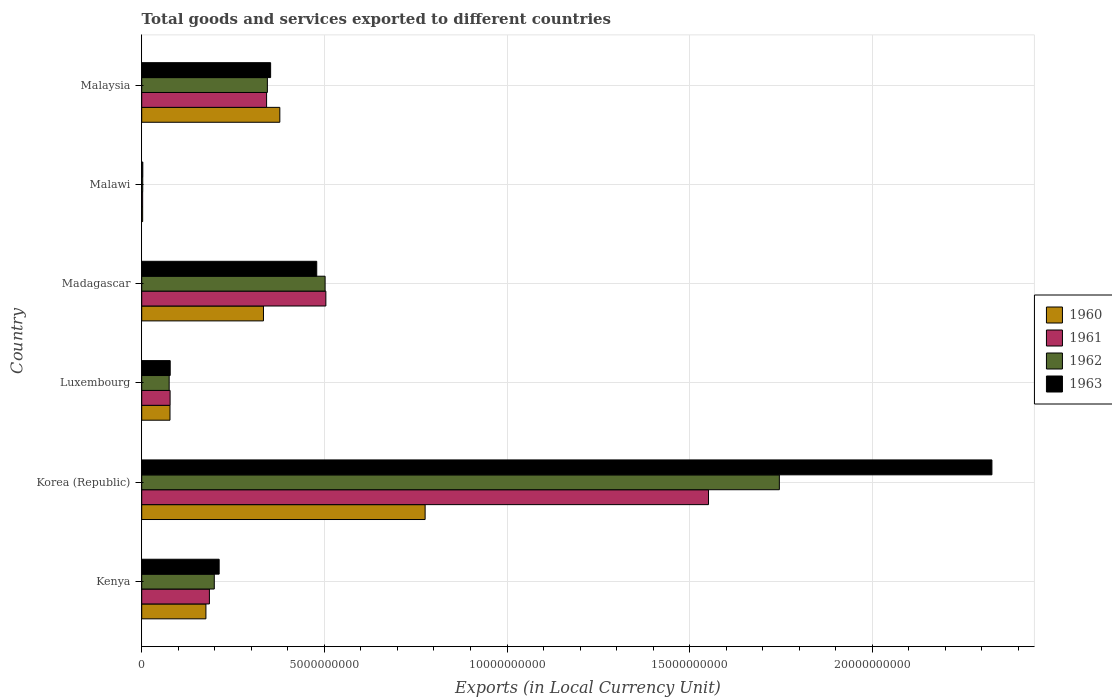How many different coloured bars are there?
Provide a succinct answer. 4. Are the number of bars on each tick of the Y-axis equal?
Your answer should be compact. Yes. How many bars are there on the 6th tick from the top?
Your response must be concise. 4. What is the label of the 4th group of bars from the top?
Ensure brevity in your answer.  Luxembourg. In how many cases, is the number of bars for a given country not equal to the number of legend labels?
Your answer should be very brief. 0. What is the Amount of goods and services exports in 1961 in Madagascar?
Give a very brief answer. 5.04e+09. Across all countries, what is the maximum Amount of goods and services exports in 1963?
Make the answer very short. 2.33e+1. Across all countries, what is the minimum Amount of goods and services exports in 1961?
Keep it short and to the point. 2.57e+07. In which country was the Amount of goods and services exports in 1962 minimum?
Ensure brevity in your answer.  Malawi. What is the total Amount of goods and services exports in 1961 in the graph?
Your response must be concise. 2.66e+1. What is the difference between the Amount of goods and services exports in 1962 in Kenya and that in Malawi?
Make the answer very short. 1.96e+09. What is the difference between the Amount of goods and services exports in 1961 in Malaysia and the Amount of goods and services exports in 1960 in Madagascar?
Offer a terse response. 8.57e+07. What is the average Amount of goods and services exports in 1961 per country?
Your response must be concise. 4.44e+09. What is the difference between the Amount of goods and services exports in 1961 and Amount of goods and services exports in 1960 in Kenya?
Offer a very short reply. 9.56e+07. What is the ratio of the Amount of goods and services exports in 1963 in Madagascar to that in Malawi?
Your response must be concise. 160.78. Is the difference between the Amount of goods and services exports in 1961 in Korea (Republic) and Madagascar greater than the difference between the Amount of goods and services exports in 1960 in Korea (Republic) and Madagascar?
Make the answer very short. Yes. What is the difference between the highest and the second highest Amount of goods and services exports in 1963?
Offer a terse response. 1.85e+1. What is the difference between the highest and the lowest Amount of goods and services exports in 1961?
Provide a succinct answer. 1.55e+1. In how many countries, is the Amount of goods and services exports in 1962 greater than the average Amount of goods and services exports in 1962 taken over all countries?
Give a very brief answer. 2. Is it the case that in every country, the sum of the Amount of goods and services exports in 1961 and Amount of goods and services exports in 1963 is greater than the sum of Amount of goods and services exports in 1962 and Amount of goods and services exports in 1960?
Keep it short and to the point. No. What does the 1st bar from the top in Luxembourg represents?
Your response must be concise. 1963. What does the 1st bar from the bottom in Madagascar represents?
Keep it short and to the point. 1960. What is the difference between two consecutive major ticks on the X-axis?
Your response must be concise. 5.00e+09. Are the values on the major ticks of X-axis written in scientific E-notation?
Make the answer very short. No. Does the graph contain grids?
Your answer should be very brief. Yes. Where does the legend appear in the graph?
Ensure brevity in your answer.  Center right. How many legend labels are there?
Offer a very short reply. 4. How are the legend labels stacked?
Offer a very short reply. Vertical. What is the title of the graph?
Make the answer very short. Total goods and services exported to different countries. What is the label or title of the X-axis?
Your answer should be very brief. Exports (in Local Currency Unit). What is the Exports (in Local Currency Unit) in 1960 in Kenya?
Your answer should be compact. 1.76e+09. What is the Exports (in Local Currency Unit) of 1961 in Kenya?
Give a very brief answer. 1.85e+09. What is the Exports (in Local Currency Unit) in 1962 in Kenya?
Your answer should be compact. 1.99e+09. What is the Exports (in Local Currency Unit) of 1963 in Kenya?
Provide a succinct answer. 2.12e+09. What is the Exports (in Local Currency Unit) in 1960 in Korea (Republic)?
Your answer should be compact. 7.76e+09. What is the Exports (in Local Currency Unit) of 1961 in Korea (Republic)?
Provide a succinct answer. 1.55e+1. What is the Exports (in Local Currency Unit) in 1962 in Korea (Republic)?
Provide a short and direct response. 1.75e+1. What is the Exports (in Local Currency Unit) in 1963 in Korea (Republic)?
Keep it short and to the point. 2.33e+1. What is the Exports (in Local Currency Unit) in 1960 in Luxembourg?
Make the answer very short. 7.74e+08. What is the Exports (in Local Currency Unit) of 1961 in Luxembourg?
Your answer should be compact. 7.77e+08. What is the Exports (in Local Currency Unit) in 1962 in Luxembourg?
Your answer should be very brief. 7.52e+08. What is the Exports (in Local Currency Unit) of 1963 in Luxembourg?
Keep it short and to the point. 7.80e+08. What is the Exports (in Local Currency Unit) of 1960 in Madagascar?
Your response must be concise. 3.33e+09. What is the Exports (in Local Currency Unit) in 1961 in Madagascar?
Make the answer very short. 5.04e+09. What is the Exports (in Local Currency Unit) in 1962 in Madagascar?
Keep it short and to the point. 5.02e+09. What is the Exports (in Local Currency Unit) of 1963 in Madagascar?
Offer a terse response. 4.79e+09. What is the Exports (in Local Currency Unit) in 1960 in Malawi?
Provide a short and direct response. 2.57e+07. What is the Exports (in Local Currency Unit) of 1961 in Malawi?
Offer a very short reply. 2.57e+07. What is the Exports (in Local Currency Unit) in 1962 in Malawi?
Offer a terse response. 2.80e+07. What is the Exports (in Local Currency Unit) in 1963 in Malawi?
Offer a very short reply. 2.98e+07. What is the Exports (in Local Currency Unit) in 1960 in Malaysia?
Offer a very short reply. 3.78e+09. What is the Exports (in Local Currency Unit) in 1961 in Malaysia?
Keep it short and to the point. 3.42e+09. What is the Exports (in Local Currency Unit) in 1962 in Malaysia?
Provide a short and direct response. 3.44e+09. What is the Exports (in Local Currency Unit) of 1963 in Malaysia?
Your answer should be compact. 3.53e+09. Across all countries, what is the maximum Exports (in Local Currency Unit) in 1960?
Your answer should be compact. 7.76e+09. Across all countries, what is the maximum Exports (in Local Currency Unit) in 1961?
Ensure brevity in your answer.  1.55e+1. Across all countries, what is the maximum Exports (in Local Currency Unit) of 1962?
Make the answer very short. 1.75e+1. Across all countries, what is the maximum Exports (in Local Currency Unit) of 1963?
Make the answer very short. 2.33e+1. Across all countries, what is the minimum Exports (in Local Currency Unit) in 1960?
Provide a short and direct response. 2.57e+07. Across all countries, what is the minimum Exports (in Local Currency Unit) of 1961?
Ensure brevity in your answer.  2.57e+07. Across all countries, what is the minimum Exports (in Local Currency Unit) in 1962?
Ensure brevity in your answer.  2.80e+07. Across all countries, what is the minimum Exports (in Local Currency Unit) of 1963?
Make the answer very short. 2.98e+07. What is the total Exports (in Local Currency Unit) in 1960 in the graph?
Your answer should be compact. 1.74e+1. What is the total Exports (in Local Currency Unit) in 1961 in the graph?
Your answer should be compact. 2.66e+1. What is the total Exports (in Local Currency Unit) of 1962 in the graph?
Offer a terse response. 2.87e+1. What is the total Exports (in Local Currency Unit) of 1963 in the graph?
Make the answer very short. 3.45e+1. What is the difference between the Exports (in Local Currency Unit) in 1960 in Kenya and that in Korea (Republic)?
Offer a very short reply. -6.00e+09. What is the difference between the Exports (in Local Currency Unit) in 1961 in Kenya and that in Korea (Republic)?
Offer a very short reply. -1.37e+1. What is the difference between the Exports (in Local Currency Unit) in 1962 in Kenya and that in Korea (Republic)?
Keep it short and to the point. -1.55e+1. What is the difference between the Exports (in Local Currency Unit) in 1963 in Kenya and that in Korea (Republic)?
Ensure brevity in your answer.  -2.12e+1. What is the difference between the Exports (in Local Currency Unit) of 1960 in Kenya and that in Luxembourg?
Your answer should be very brief. 9.84e+08. What is the difference between the Exports (in Local Currency Unit) in 1961 in Kenya and that in Luxembourg?
Offer a very short reply. 1.08e+09. What is the difference between the Exports (in Local Currency Unit) of 1962 in Kenya and that in Luxembourg?
Provide a short and direct response. 1.23e+09. What is the difference between the Exports (in Local Currency Unit) in 1963 in Kenya and that in Luxembourg?
Provide a short and direct response. 1.34e+09. What is the difference between the Exports (in Local Currency Unit) of 1960 in Kenya and that in Madagascar?
Make the answer very short. -1.58e+09. What is the difference between the Exports (in Local Currency Unit) of 1961 in Kenya and that in Madagascar?
Offer a very short reply. -3.19e+09. What is the difference between the Exports (in Local Currency Unit) of 1962 in Kenya and that in Madagascar?
Provide a succinct answer. -3.03e+09. What is the difference between the Exports (in Local Currency Unit) of 1963 in Kenya and that in Madagascar?
Make the answer very short. -2.67e+09. What is the difference between the Exports (in Local Currency Unit) in 1960 in Kenya and that in Malawi?
Ensure brevity in your answer.  1.73e+09. What is the difference between the Exports (in Local Currency Unit) of 1961 in Kenya and that in Malawi?
Your response must be concise. 1.83e+09. What is the difference between the Exports (in Local Currency Unit) in 1962 in Kenya and that in Malawi?
Your answer should be compact. 1.96e+09. What is the difference between the Exports (in Local Currency Unit) in 1963 in Kenya and that in Malawi?
Make the answer very short. 2.09e+09. What is the difference between the Exports (in Local Currency Unit) in 1960 in Kenya and that in Malaysia?
Provide a short and direct response. -2.02e+09. What is the difference between the Exports (in Local Currency Unit) in 1961 in Kenya and that in Malaysia?
Provide a short and direct response. -1.57e+09. What is the difference between the Exports (in Local Currency Unit) in 1962 in Kenya and that in Malaysia?
Your response must be concise. -1.45e+09. What is the difference between the Exports (in Local Currency Unit) in 1963 in Kenya and that in Malaysia?
Give a very brief answer. -1.41e+09. What is the difference between the Exports (in Local Currency Unit) in 1960 in Korea (Republic) and that in Luxembourg?
Provide a short and direct response. 6.98e+09. What is the difference between the Exports (in Local Currency Unit) in 1961 in Korea (Republic) and that in Luxembourg?
Ensure brevity in your answer.  1.47e+1. What is the difference between the Exports (in Local Currency Unit) in 1962 in Korea (Republic) and that in Luxembourg?
Keep it short and to the point. 1.67e+1. What is the difference between the Exports (in Local Currency Unit) in 1963 in Korea (Republic) and that in Luxembourg?
Make the answer very short. 2.25e+1. What is the difference between the Exports (in Local Currency Unit) of 1960 in Korea (Republic) and that in Madagascar?
Your response must be concise. 4.43e+09. What is the difference between the Exports (in Local Currency Unit) in 1961 in Korea (Republic) and that in Madagascar?
Offer a very short reply. 1.05e+1. What is the difference between the Exports (in Local Currency Unit) of 1962 in Korea (Republic) and that in Madagascar?
Your response must be concise. 1.24e+1. What is the difference between the Exports (in Local Currency Unit) in 1963 in Korea (Republic) and that in Madagascar?
Offer a terse response. 1.85e+1. What is the difference between the Exports (in Local Currency Unit) of 1960 in Korea (Republic) and that in Malawi?
Offer a terse response. 7.73e+09. What is the difference between the Exports (in Local Currency Unit) in 1961 in Korea (Republic) and that in Malawi?
Offer a very short reply. 1.55e+1. What is the difference between the Exports (in Local Currency Unit) in 1962 in Korea (Republic) and that in Malawi?
Provide a short and direct response. 1.74e+1. What is the difference between the Exports (in Local Currency Unit) in 1963 in Korea (Republic) and that in Malawi?
Ensure brevity in your answer.  2.32e+1. What is the difference between the Exports (in Local Currency Unit) of 1960 in Korea (Republic) and that in Malaysia?
Give a very brief answer. 3.98e+09. What is the difference between the Exports (in Local Currency Unit) of 1961 in Korea (Republic) and that in Malaysia?
Provide a succinct answer. 1.21e+1. What is the difference between the Exports (in Local Currency Unit) of 1962 in Korea (Republic) and that in Malaysia?
Ensure brevity in your answer.  1.40e+1. What is the difference between the Exports (in Local Currency Unit) in 1963 in Korea (Republic) and that in Malaysia?
Ensure brevity in your answer.  1.97e+1. What is the difference between the Exports (in Local Currency Unit) in 1960 in Luxembourg and that in Madagascar?
Your answer should be compact. -2.56e+09. What is the difference between the Exports (in Local Currency Unit) in 1961 in Luxembourg and that in Madagascar?
Ensure brevity in your answer.  -4.26e+09. What is the difference between the Exports (in Local Currency Unit) of 1962 in Luxembourg and that in Madagascar?
Make the answer very short. -4.27e+09. What is the difference between the Exports (in Local Currency Unit) of 1963 in Luxembourg and that in Madagascar?
Your answer should be compact. -4.01e+09. What is the difference between the Exports (in Local Currency Unit) in 1960 in Luxembourg and that in Malawi?
Your answer should be very brief. 7.48e+08. What is the difference between the Exports (in Local Currency Unit) of 1961 in Luxembourg and that in Malawi?
Your response must be concise. 7.51e+08. What is the difference between the Exports (in Local Currency Unit) in 1962 in Luxembourg and that in Malawi?
Your answer should be compact. 7.24e+08. What is the difference between the Exports (in Local Currency Unit) in 1963 in Luxembourg and that in Malawi?
Ensure brevity in your answer.  7.50e+08. What is the difference between the Exports (in Local Currency Unit) in 1960 in Luxembourg and that in Malaysia?
Provide a short and direct response. -3.01e+09. What is the difference between the Exports (in Local Currency Unit) in 1961 in Luxembourg and that in Malaysia?
Offer a terse response. -2.64e+09. What is the difference between the Exports (in Local Currency Unit) of 1962 in Luxembourg and that in Malaysia?
Your response must be concise. -2.69e+09. What is the difference between the Exports (in Local Currency Unit) in 1963 in Luxembourg and that in Malaysia?
Your response must be concise. -2.75e+09. What is the difference between the Exports (in Local Currency Unit) of 1960 in Madagascar and that in Malawi?
Make the answer very short. 3.31e+09. What is the difference between the Exports (in Local Currency Unit) in 1961 in Madagascar and that in Malawi?
Offer a terse response. 5.02e+09. What is the difference between the Exports (in Local Currency Unit) of 1962 in Madagascar and that in Malawi?
Make the answer very short. 4.99e+09. What is the difference between the Exports (in Local Currency Unit) in 1963 in Madagascar and that in Malawi?
Your answer should be compact. 4.76e+09. What is the difference between the Exports (in Local Currency Unit) in 1960 in Madagascar and that in Malaysia?
Your response must be concise. -4.48e+08. What is the difference between the Exports (in Local Currency Unit) in 1961 in Madagascar and that in Malaysia?
Provide a succinct answer. 1.62e+09. What is the difference between the Exports (in Local Currency Unit) in 1962 in Madagascar and that in Malaysia?
Make the answer very short. 1.58e+09. What is the difference between the Exports (in Local Currency Unit) of 1963 in Madagascar and that in Malaysia?
Give a very brief answer. 1.26e+09. What is the difference between the Exports (in Local Currency Unit) of 1960 in Malawi and that in Malaysia?
Make the answer very short. -3.76e+09. What is the difference between the Exports (in Local Currency Unit) in 1961 in Malawi and that in Malaysia?
Give a very brief answer. -3.39e+09. What is the difference between the Exports (in Local Currency Unit) in 1962 in Malawi and that in Malaysia?
Your answer should be compact. -3.41e+09. What is the difference between the Exports (in Local Currency Unit) in 1963 in Malawi and that in Malaysia?
Give a very brief answer. -3.50e+09. What is the difference between the Exports (in Local Currency Unit) in 1960 in Kenya and the Exports (in Local Currency Unit) in 1961 in Korea (Republic)?
Provide a succinct answer. -1.38e+1. What is the difference between the Exports (in Local Currency Unit) of 1960 in Kenya and the Exports (in Local Currency Unit) of 1962 in Korea (Republic)?
Keep it short and to the point. -1.57e+1. What is the difference between the Exports (in Local Currency Unit) of 1960 in Kenya and the Exports (in Local Currency Unit) of 1963 in Korea (Republic)?
Offer a very short reply. -2.15e+1. What is the difference between the Exports (in Local Currency Unit) of 1961 in Kenya and the Exports (in Local Currency Unit) of 1962 in Korea (Republic)?
Your answer should be very brief. -1.56e+1. What is the difference between the Exports (in Local Currency Unit) of 1961 in Kenya and the Exports (in Local Currency Unit) of 1963 in Korea (Republic)?
Your response must be concise. -2.14e+1. What is the difference between the Exports (in Local Currency Unit) in 1962 in Kenya and the Exports (in Local Currency Unit) in 1963 in Korea (Republic)?
Your response must be concise. -2.13e+1. What is the difference between the Exports (in Local Currency Unit) of 1960 in Kenya and the Exports (in Local Currency Unit) of 1961 in Luxembourg?
Give a very brief answer. 9.81e+08. What is the difference between the Exports (in Local Currency Unit) in 1960 in Kenya and the Exports (in Local Currency Unit) in 1962 in Luxembourg?
Provide a short and direct response. 1.01e+09. What is the difference between the Exports (in Local Currency Unit) of 1960 in Kenya and the Exports (in Local Currency Unit) of 1963 in Luxembourg?
Give a very brief answer. 9.78e+08. What is the difference between the Exports (in Local Currency Unit) in 1961 in Kenya and the Exports (in Local Currency Unit) in 1962 in Luxembourg?
Your answer should be very brief. 1.10e+09. What is the difference between the Exports (in Local Currency Unit) of 1961 in Kenya and the Exports (in Local Currency Unit) of 1963 in Luxembourg?
Ensure brevity in your answer.  1.07e+09. What is the difference between the Exports (in Local Currency Unit) in 1962 in Kenya and the Exports (in Local Currency Unit) in 1963 in Luxembourg?
Provide a short and direct response. 1.21e+09. What is the difference between the Exports (in Local Currency Unit) of 1960 in Kenya and the Exports (in Local Currency Unit) of 1961 in Madagascar?
Ensure brevity in your answer.  -3.28e+09. What is the difference between the Exports (in Local Currency Unit) of 1960 in Kenya and the Exports (in Local Currency Unit) of 1962 in Madagascar?
Give a very brief answer. -3.26e+09. What is the difference between the Exports (in Local Currency Unit) in 1960 in Kenya and the Exports (in Local Currency Unit) in 1963 in Madagascar?
Ensure brevity in your answer.  -3.03e+09. What is the difference between the Exports (in Local Currency Unit) in 1961 in Kenya and the Exports (in Local Currency Unit) in 1962 in Madagascar?
Offer a terse response. -3.17e+09. What is the difference between the Exports (in Local Currency Unit) in 1961 in Kenya and the Exports (in Local Currency Unit) in 1963 in Madagascar?
Ensure brevity in your answer.  -2.94e+09. What is the difference between the Exports (in Local Currency Unit) of 1962 in Kenya and the Exports (in Local Currency Unit) of 1963 in Madagascar?
Keep it short and to the point. -2.80e+09. What is the difference between the Exports (in Local Currency Unit) in 1960 in Kenya and the Exports (in Local Currency Unit) in 1961 in Malawi?
Make the answer very short. 1.73e+09. What is the difference between the Exports (in Local Currency Unit) of 1960 in Kenya and the Exports (in Local Currency Unit) of 1962 in Malawi?
Provide a succinct answer. 1.73e+09. What is the difference between the Exports (in Local Currency Unit) of 1960 in Kenya and the Exports (in Local Currency Unit) of 1963 in Malawi?
Give a very brief answer. 1.73e+09. What is the difference between the Exports (in Local Currency Unit) in 1961 in Kenya and the Exports (in Local Currency Unit) in 1962 in Malawi?
Offer a very short reply. 1.83e+09. What is the difference between the Exports (in Local Currency Unit) in 1961 in Kenya and the Exports (in Local Currency Unit) in 1963 in Malawi?
Give a very brief answer. 1.82e+09. What is the difference between the Exports (in Local Currency Unit) in 1962 in Kenya and the Exports (in Local Currency Unit) in 1963 in Malawi?
Offer a very short reply. 1.96e+09. What is the difference between the Exports (in Local Currency Unit) in 1960 in Kenya and the Exports (in Local Currency Unit) in 1961 in Malaysia?
Your answer should be compact. -1.66e+09. What is the difference between the Exports (in Local Currency Unit) in 1960 in Kenya and the Exports (in Local Currency Unit) in 1962 in Malaysia?
Offer a terse response. -1.68e+09. What is the difference between the Exports (in Local Currency Unit) of 1960 in Kenya and the Exports (in Local Currency Unit) of 1963 in Malaysia?
Offer a terse response. -1.77e+09. What is the difference between the Exports (in Local Currency Unit) in 1961 in Kenya and the Exports (in Local Currency Unit) in 1962 in Malaysia?
Offer a terse response. -1.59e+09. What is the difference between the Exports (in Local Currency Unit) in 1961 in Kenya and the Exports (in Local Currency Unit) in 1963 in Malaysia?
Keep it short and to the point. -1.68e+09. What is the difference between the Exports (in Local Currency Unit) of 1962 in Kenya and the Exports (in Local Currency Unit) of 1963 in Malaysia?
Provide a succinct answer. -1.54e+09. What is the difference between the Exports (in Local Currency Unit) in 1960 in Korea (Republic) and the Exports (in Local Currency Unit) in 1961 in Luxembourg?
Ensure brevity in your answer.  6.98e+09. What is the difference between the Exports (in Local Currency Unit) in 1960 in Korea (Republic) and the Exports (in Local Currency Unit) in 1962 in Luxembourg?
Your answer should be compact. 7.01e+09. What is the difference between the Exports (in Local Currency Unit) in 1960 in Korea (Republic) and the Exports (in Local Currency Unit) in 1963 in Luxembourg?
Your response must be concise. 6.98e+09. What is the difference between the Exports (in Local Currency Unit) in 1961 in Korea (Republic) and the Exports (in Local Currency Unit) in 1962 in Luxembourg?
Provide a succinct answer. 1.48e+1. What is the difference between the Exports (in Local Currency Unit) in 1961 in Korea (Republic) and the Exports (in Local Currency Unit) in 1963 in Luxembourg?
Make the answer very short. 1.47e+1. What is the difference between the Exports (in Local Currency Unit) of 1962 in Korea (Republic) and the Exports (in Local Currency Unit) of 1963 in Luxembourg?
Provide a succinct answer. 1.67e+1. What is the difference between the Exports (in Local Currency Unit) in 1960 in Korea (Republic) and the Exports (in Local Currency Unit) in 1961 in Madagascar?
Provide a short and direct response. 2.72e+09. What is the difference between the Exports (in Local Currency Unit) of 1960 in Korea (Republic) and the Exports (in Local Currency Unit) of 1962 in Madagascar?
Offer a very short reply. 2.74e+09. What is the difference between the Exports (in Local Currency Unit) in 1960 in Korea (Republic) and the Exports (in Local Currency Unit) in 1963 in Madagascar?
Your answer should be very brief. 2.97e+09. What is the difference between the Exports (in Local Currency Unit) of 1961 in Korea (Republic) and the Exports (in Local Currency Unit) of 1962 in Madagascar?
Offer a very short reply. 1.05e+1. What is the difference between the Exports (in Local Currency Unit) of 1961 in Korea (Republic) and the Exports (in Local Currency Unit) of 1963 in Madagascar?
Provide a succinct answer. 1.07e+1. What is the difference between the Exports (in Local Currency Unit) in 1962 in Korea (Republic) and the Exports (in Local Currency Unit) in 1963 in Madagascar?
Offer a very short reply. 1.27e+1. What is the difference between the Exports (in Local Currency Unit) in 1960 in Korea (Republic) and the Exports (in Local Currency Unit) in 1961 in Malawi?
Your answer should be very brief. 7.73e+09. What is the difference between the Exports (in Local Currency Unit) in 1960 in Korea (Republic) and the Exports (in Local Currency Unit) in 1962 in Malawi?
Keep it short and to the point. 7.73e+09. What is the difference between the Exports (in Local Currency Unit) in 1960 in Korea (Republic) and the Exports (in Local Currency Unit) in 1963 in Malawi?
Your answer should be very brief. 7.73e+09. What is the difference between the Exports (in Local Currency Unit) of 1961 in Korea (Republic) and the Exports (in Local Currency Unit) of 1962 in Malawi?
Your answer should be compact. 1.55e+1. What is the difference between the Exports (in Local Currency Unit) of 1961 in Korea (Republic) and the Exports (in Local Currency Unit) of 1963 in Malawi?
Give a very brief answer. 1.55e+1. What is the difference between the Exports (in Local Currency Unit) in 1962 in Korea (Republic) and the Exports (in Local Currency Unit) in 1963 in Malawi?
Keep it short and to the point. 1.74e+1. What is the difference between the Exports (in Local Currency Unit) of 1960 in Korea (Republic) and the Exports (in Local Currency Unit) of 1961 in Malaysia?
Your answer should be very brief. 4.34e+09. What is the difference between the Exports (in Local Currency Unit) of 1960 in Korea (Republic) and the Exports (in Local Currency Unit) of 1962 in Malaysia?
Offer a very short reply. 4.32e+09. What is the difference between the Exports (in Local Currency Unit) in 1960 in Korea (Republic) and the Exports (in Local Currency Unit) in 1963 in Malaysia?
Your answer should be very brief. 4.23e+09. What is the difference between the Exports (in Local Currency Unit) of 1961 in Korea (Republic) and the Exports (in Local Currency Unit) of 1962 in Malaysia?
Your response must be concise. 1.21e+1. What is the difference between the Exports (in Local Currency Unit) in 1961 in Korea (Republic) and the Exports (in Local Currency Unit) in 1963 in Malaysia?
Ensure brevity in your answer.  1.20e+1. What is the difference between the Exports (in Local Currency Unit) in 1962 in Korea (Republic) and the Exports (in Local Currency Unit) in 1963 in Malaysia?
Provide a short and direct response. 1.39e+1. What is the difference between the Exports (in Local Currency Unit) in 1960 in Luxembourg and the Exports (in Local Currency Unit) in 1961 in Madagascar?
Offer a very short reply. -4.27e+09. What is the difference between the Exports (in Local Currency Unit) of 1960 in Luxembourg and the Exports (in Local Currency Unit) of 1962 in Madagascar?
Your response must be concise. -4.25e+09. What is the difference between the Exports (in Local Currency Unit) in 1960 in Luxembourg and the Exports (in Local Currency Unit) in 1963 in Madagascar?
Your response must be concise. -4.02e+09. What is the difference between the Exports (in Local Currency Unit) of 1961 in Luxembourg and the Exports (in Local Currency Unit) of 1962 in Madagascar?
Offer a terse response. -4.24e+09. What is the difference between the Exports (in Local Currency Unit) in 1961 in Luxembourg and the Exports (in Local Currency Unit) in 1963 in Madagascar?
Your answer should be compact. -4.01e+09. What is the difference between the Exports (in Local Currency Unit) in 1962 in Luxembourg and the Exports (in Local Currency Unit) in 1963 in Madagascar?
Give a very brief answer. -4.04e+09. What is the difference between the Exports (in Local Currency Unit) in 1960 in Luxembourg and the Exports (in Local Currency Unit) in 1961 in Malawi?
Provide a short and direct response. 7.48e+08. What is the difference between the Exports (in Local Currency Unit) of 1960 in Luxembourg and the Exports (in Local Currency Unit) of 1962 in Malawi?
Make the answer very short. 7.46e+08. What is the difference between the Exports (in Local Currency Unit) of 1960 in Luxembourg and the Exports (in Local Currency Unit) of 1963 in Malawi?
Provide a short and direct response. 7.44e+08. What is the difference between the Exports (in Local Currency Unit) of 1961 in Luxembourg and the Exports (in Local Currency Unit) of 1962 in Malawi?
Make the answer very short. 7.49e+08. What is the difference between the Exports (in Local Currency Unit) in 1961 in Luxembourg and the Exports (in Local Currency Unit) in 1963 in Malawi?
Your response must be concise. 7.47e+08. What is the difference between the Exports (in Local Currency Unit) of 1962 in Luxembourg and the Exports (in Local Currency Unit) of 1963 in Malawi?
Offer a terse response. 7.22e+08. What is the difference between the Exports (in Local Currency Unit) in 1960 in Luxembourg and the Exports (in Local Currency Unit) in 1961 in Malaysia?
Your answer should be very brief. -2.64e+09. What is the difference between the Exports (in Local Currency Unit) of 1960 in Luxembourg and the Exports (in Local Currency Unit) of 1962 in Malaysia?
Provide a short and direct response. -2.67e+09. What is the difference between the Exports (in Local Currency Unit) in 1960 in Luxembourg and the Exports (in Local Currency Unit) in 1963 in Malaysia?
Provide a short and direct response. -2.76e+09. What is the difference between the Exports (in Local Currency Unit) of 1961 in Luxembourg and the Exports (in Local Currency Unit) of 1962 in Malaysia?
Provide a succinct answer. -2.66e+09. What is the difference between the Exports (in Local Currency Unit) in 1961 in Luxembourg and the Exports (in Local Currency Unit) in 1963 in Malaysia?
Keep it short and to the point. -2.75e+09. What is the difference between the Exports (in Local Currency Unit) of 1962 in Luxembourg and the Exports (in Local Currency Unit) of 1963 in Malaysia?
Provide a succinct answer. -2.78e+09. What is the difference between the Exports (in Local Currency Unit) in 1960 in Madagascar and the Exports (in Local Currency Unit) in 1961 in Malawi?
Keep it short and to the point. 3.31e+09. What is the difference between the Exports (in Local Currency Unit) of 1960 in Madagascar and the Exports (in Local Currency Unit) of 1962 in Malawi?
Give a very brief answer. 3.31e+09. What is the difference between the Exports (in Local Currency Unit) of 1960 in Madagascar and the Exports (in Local Currency Unit) of 1963 in Malawi?
Offer a terse response. 3.30e+09. What is the difference between the Exports (in Local Currency Unit) in 1961 in Madagascar and the Exports (in Local Currency Unit) in 1962 in Malawi?
Offer a very short reply. 5.01e+09. What is the difference between the Exports (in Local Currency Unit) in 1961 in Madagascar and the Exports (in Local Currency Unit) in 1963 in Malawi?
Provide a short and direct response. 5.01e+09. What is the difference between the Exports (in Local Currency Unit) in 1962 in Madagascar and the Exports (in Local Currency Unit) in 1963 in Malawi?
Keep it short and to the point. 4.99e+09. What is the difference between the Exports (in Local Currency Unit) of 1960 in Madagascar and the Exports (in Local Currency Unit) of 1961 in Malaysia?
Give a very brief answer. -8.57e+07. What is the difference between the Exports (in Local Currency Unit) of 1960 in Madagascar and the Exports (in Local Currency Unit) of 1962 in Malaysia?
Give a very brief answer. -1.07e+08. What is the difference between the Exports (in Local Currency Unit) in 1960 in Madagascar and the Exports (in Local Currency Unit) in 1963 in Malaysia?
Give a very brief answer. -1.96e+08. What is the difference between the Exports (in Local Currency Unit) in 1961 in Madagascar and the Exports (in Local Currency Unit) in 1962 in Malaysia?
Keep it short and to the point. 1.60e+09. What is the difference between the Exports (in Local Currency Unit) in 1961 in Madagascar and the Exports (in Local Currency Unit) in 1963 in Malaysia?
Offer a very short reply. 1.51e+09. What is the difference between the Exports (in Local Currency Unit) in 1962 in Madagascar and the Exports (in Local Currency Unit) in 1963 in Malaysia?
Provide a short and direct response. 1.49e+09. What is the difference between the Exports (in Local Currency Unit) in 1960 in Malawi and the Exports (in Local Currency Unit) in 1961 in Malaysia?
Provide a short and direct response. -3.39e+09. What is the difference between the Exports (in Local Currency Unit) in 1960 in Malawi and the Exports (in Local Currency Unit) in 1962 in Malaysia?
Give a very brief answer. -3.41e+09. What is the difference between the Exports (in Local Currency Unit) of 1960 in Malawi and the Exports (in Local Currency Unit) of 1963 in Malaysia?
Your response must be concise. -3.50e+09. What is the difference between the Exports (in Local Currency Unit) of 1961 in Malawi and the Exports (in Local Currency Unit) of 1962 in Malaysia?
Give a very brief answer. -3.41e+09. What is the difference between the Exports (in Local Currency Unit) in 1961 in Malawi and the Exports (in Local Currency Unit) in 1963 in Malaysia?
Your answer should be compact. -3.50e+09. What is the difference between the Exports (in Local Currency Unit) in 1962 in Malawi and the Exports (in Local Currency Unit) in 1963 in Malaysia?
Give a very brief answer. -3.50e+09. What is the average Exports (in Local Currency Unit) in 1960 per country?
Ensure brevity in your answer.  2.90e+09. What is the average Exports (in Local Currency Unit) in 1961 per country?
Provide a succinct answer. 4.44e+09. What is the average Exports (in Local Currency Unit) of 1962 per country?
Your response must be concise. 4.78e+09. What is the average Exports (in Local Currency Unit) of 1963 per country?
Make the answer very short. 5.75e+09. What is the difference between the Exports (in Local Currency Unit) in 1960 and Exports (in Local Currency Unit) in 1961 in Kenya?
Your answer should be very brief. -9.56e+07. What is the difference between the Exports (in Local Currency Unit) of 1960 and Exports (in Local Currency Unit) of 1962 in Kenya?
Make the answer very short. -2.29e+08. What is the difference between the Exports (in Local Currency Unit) in 1960 and Exports (in Local Currency Unit) in 1963 in Kenya?
Provide a succinct answer. -3.63e+08. What is the difference between the Exports (in Local Currency Unit) in 1961 and Exports (in Local Currency Unit) in 1962 in Kenya?
Provide a short and direct response. -1.33e+08. What is the difference between the Exports (in Local Currency Unit) in 1961 and Exports (in Local Currency Unit) in 1963 in Kenya?
Your answer should be very brief. -2.67e+08. What is the difference between the Exports (in Local Currency Unit) of 1962 and Exports (in Local Currency Unit) of 1963 in Kenya?
Keep it short and to the point. -1.34e+08. What is the difference between the Exports (in Local Currency Unit) of 1960 and Exports (in Local Currency Unit) of 1961 in Korea (Republic)?
Your answer should be very brief. -7.76e+09. What is the difference between the Exports (in Local Currency Unit) of 1960 and Exports (in Local Currency Unit) of 1962 in Korea (Republic)?
Keep it short and to the point. -9.70e+09. What is the difference between the Exports (in Local Currency Unit) of 1960 and Exports (in Local Currency Unit) of 1963 in Korea (Republic)?
Provide a succinct answer. -1.55e+1. What is the difference between the Exports (in Local Currency Unit) in 1961 and Exports (in Local Currency Unit) in 1962 in Korea (Republic)?
Make the answer very short. -1.94e+09. What is the difference between the Exports (in Local Currency Unit) in 1961 and Exports (in Local Currency Unit) in 1963 in Korea (Republic)?
Your answer should be very brief. -7.76e+09. What is the difference between the Exports (in Local Currency Unit) of 1962 and Exports (in Local Currency Unit) of 1963 in Korea (Republic)?
Provide a succinct answer. -5.82e+09. What is the difference between the Exports (in Local Currency Unit) of 1960 and Exports (in Local Currency Unit) of 1961 in Luxembourg?
Keep it short and to the point. -2.86e+06. What is the difference between the Exports (in Local Currency Unit) in 1960 and Exports (in Local Currency Unit) in 1962 in Luxembourg?
Offer a terse response. 2.23e+07. What is the difference between the Exports (in Local Currency Unit) of 1960 and Exports (in Local Currency Unit) of 1963 in Luxembourg?
Your answer should be very brief. -5.65e+06. What is the difference between the Exports (in Local Currency Unit) in 1961 and Exports (in Local Currency Unit) in 1962 in Luxembourg?
Offer a terse response. 2.52e+07. What is the difference between the Exports (in Local Currency Unit) in 1961 and Exports (in Local Currency Unit) in 1963 in Luxembourg?
Offer a very short reply. -2.79e+06. What is the difference between the Exports (in Local Currency Unit) of 1962 and Exports (in Local Currency Unit) of 1963 in Luxembourg?
Your response must be concise. -2.80e+07. What is the difference between the Exports (in Local Currency Unit) of 1960 and Exports (in Local Currency Unit) of 1961 in Madagascar?
Make the answer very short. -1.71e+09. What is the difference between the Exports (in Local Currency Unit) in 1960 and Exports (in Local Currency Unit) in 1962 in Madagascar?
Provide a succinct answer. -1.69e+09. What is the difference between the Exports (in Local Currency Unit) in 1960 and Exports (in Local Currency Unit) in 1963 in Madagascar?
Provide a succinct answer. -1.46e+09. What is the difference between the Exports (in Local Currency Unit) of 1961 and Exports (in Local Currency Unit) of 1962 in Madagascar?
Offer a very short reply. 2.08e+07. What is the difference between the Exports (in Local Currency Unit) of 1961 and Exports (in Local Currency Unit) of 1963 in Madagascar?
Offer a very short reply. 2.50e+08. What is the difference between the Exports (in Local Currency Unit) of 1962 and Exports (in Local Currency Unit) of 1963 in Madagascar?
Offer a very short reply. 2.29e+08. What is the difference between the Exports (in Local Currency Unit) of 1960 and Exports (in Local Currency Unit) of 1962 in Malawi?
Make the answer very short. -2.30e+06. What is the difference between the Exports (in Local Currency Unit) of 1960 and Exports (in Local Currency Unit) of 1963 in Malawi?
Provide a short and direct response. -4.10e+06. What is the difference between the Exports (in Local Currency Unit) of 1961 and Exports (in Local Currency Unit) of 1962 in Malawi?
Provide a short and direct response. -2.30e+06. What is the difference between the Exports (in Local Currency Unit) of 1961 and Exports (in Local Currency Unit) of 1963 in Malawi?
Your answer should be very brief. -4.10e+06. What is the difference between the Exports (in Local Currency Unit) in 1962 and Exports (in Local Currency Unit) in 1963 in Malawi?
Your answer should be compact. -1.80e+06. What is the difference between the Exports (in Local Currency Unit) in 1960 and Exports (in Local Currency Unit) in 1961 in Malaysia?
Offer a terse response. 3.62e+08. What is the difference between the Exports (in Local Currency Unit) in 1960 and Exports (in Local Currency Unit) in 1962 in Malaysia?
Make the answer very short. 3.41e+08. What is the difference between the Exports (in Local Currency Unit) in 1960 and Exports (in Local Currency Unit) in 1963 in Malaysia?
Provide a succinct answer. 2.52e+08. What is the difference between the Exports (in Local Currency Unit) of 1961 and Exports (in Local Currency Unit) of 1962 in Malaysia?
Your answer should be very brief. -2.11e+07. What is the difference between the Exports (in Local Currency Unit) of 1961 and Exports (in Local Currency Unit) of 1963 in Malaysia?
Give a very brief answer. -1.10e+08. What is the difference between the Exports (in Local Currency Unit) of 1962 and Exports (in Local Currency Unit) of 1963 in Malaysia?
Provide a succinct answer. -8.93e+07. What is the ratio of the Exports (in Local Currency Unit) in 1960 in Kenya to that in Korea (Republic)?
Give a very brief answer. 0.23. What is the ratio of the Exports (in Local Currency Unit) in 1961 in Kenya to that in Korea (Republic)?
Provide a short and direct response. 0.12. What is the ratio of the Exports (in Local Currency Unit) of 1962 in Kenya to that in Korea (Republic)?
Your response must be concise. 0.11. What is the ratio of the Exports (in Local Currency Unit) in 1963 in Kenya to that in Korea (Republic)?
Provide a short and direct response. 0.09. What is the ratio of the Exports (in Local Currency Unit) of 1960 in Kenya to that in Luxembourg?
Your answer should be very brief. 2.27. What is the ratio of the Exports (in Local Currency Unit) in 1961 in Kenya to that in Luxembourg?
Give a very brief answer. 2.39. What is the ratio of the Exports (in Local Currency Unit) of 1962 in Kenya to that in Luxembourg?
Keep it short and to the point. 2.64. What is the ratio of the Exports (in Local Currency Unit) of 1963 in Kenya to that in Luxembourg?
Ensure brevity in your answer.  2.72. What is the ratio of the Exports (in Local Currency Unit) of 1960 in Kenya to that in Madagascar?
Provide a short and direct response. 0.53. What is the ratio of the Exports (in Local Currency Unit) of 1961 in Kenya to that in Madagascar?
Make the answer very short. 0.37. What is the ratio of the Exports (in Local Currency Unit) of 1962 in Kenya to that in Madagascar?
Ensure brevity in your answer.  0.4. What is the ratio of the Exports (in Local Currency Unit) in 1963 in Kenya to that in Madagascar?
Keep it short and to the point. 0.44. What is the ratio of the Exports (in Local Currency Unit) of 1960 in Kenya to that in Malawi?
Provide a short and direct response. 68.39. What is the ratio of the Exports (in Local Currency Unit) of 1961 in Kenya to that in Malawi?
Your answer should be very brief. 72.11. What is the ratio of the Exports (in Local Currency Unit) in 1962 in Kenya to that in Malawi?
Ensure brevity in your answer.  70.95. What is the ratio of the Exports (in Local Currency Unit) of 1963 in Kenya to that in Malawi?
Ensure brevity in your answer.  71.14. What is the ratio of the Exports (in Local Currency Unit) of 1960 in Kenya to that in Malaysia?
Give a very brief answer. 0.46. What is the ratio of the Exports (in Local Currency Unit) of 1961 in Kenya to that in Malaysia?
Your response must be concise. 0.54. What is the ratio of the Exports (in Local Currency Unit) in 1962 in Kenya to that in Malaysia?
Provide a succinct answer. 0.58. What is the ratio of the Exports (in Local Currency Unit) in 1963 in Kenya to that in Malaysia?
Your response must be concise. 0.6. What is the ratio of the Exports (in Local Currency Unit) in 1960 in Korea (Republic) to that in Luxembourg?
Keep it short and to the point. 10.02. What is the ratio of the Exports (in Local Currency Unit) in 1961 in Korea (Republic) to that in Luxembourg?
Offer a very short reply. 19.97. What is the ratio of the Exports (in Local Currency Unit) in 1962 in Korea (Republic) to that in Luxembourg?
Offer a very short reply. 23.22. What is the ratio of the Exports (in Local Currency Unit) in 1963 in Korea (Republic) to that in Luxembourg?
Ensure brevity in your answer.  29.85. What is the ratio of the Exports (in Local Currency Unit) of 1960 in Korea (Republic) to that in Madagascar?
Your answer should be very brief. 2.33. What is the ratio of the Exports (in Local Currency Unit) in 1961 in Korea (Republic) to that in Madagascar?
Keep it short and to the point. 3.08. What is the ratio of the Exports (in Local Currency Unit) of 1962 in Korea (Republic) to that in Madagascar?
Provide a succinct answer. 3.48. What is the ratio of the Exports (in Local Currency Unit) in 1963 in Korea (Republic) to that in Madagascar?
Keep it short and to the point. 4.86. What is the ratio of the Exports (in Local Currency Unit) of 1960 in Korea (Republic) to that in Malawi?
Make the answer very short. 301.89. What is the ratio of the Exports (in Local Currency Unit) in 1961 in Korea (Republic) to that in Malawi?
Give a very brief answer. 603.78. What is the ratio of the Exports (in Local Currency Unit) of 1962 in Korea (Republic) to that in Malawi?
Ensure brevity in your answer.  623.45. What is the ratio of the Exports (in Local Currency Unit) of 1963 in Korea (Republic) to that in Malawi?
Your answer should be compact. 781.07. What is the ratio of the Exports (in Local Currency Unit) in 1960 in Korea (Republic) to that in Malaysia?
Make the answer very short. 2.05. What is the ratio of the Exports (in Local Currency Unit) of 1961 in Korea (Republic) to that in Malaysia?
Your response must be concise. 4.54. What is the ratio of the Exports (in Local Currency Unit) of 1962 in Korea (Republic) to that in Malaysia?
Your answer should be very brief. 5.07. What is the ratio of the Exports (in Local Currency Unit) of 1963 in Korea (Republic) to that in Malaysia?
Keep it short and to the point. 6.6. What is the ratio of the Exports (in Local Currency Unit) in 1960 in Luxembourg to that in Madagascar?
Give a very brief answer. 0.23. What is the ratio of the Exports (in Local Currency Unit) of 1961 in Luxembourg to that in Madagascar?
Give a very brief answer. 0.15. What is the ratio of the Exports (in Local Currency Unit) of 1962 in Luxembourg to that in Madagascar?
Keep it short and to the point. 0.15. What is the ratio of the Exports (in Local Currency Unit) of 1963 in Luxembourg to that in Madagascar?
Offer a very short reply. 0.16. What is the ratio of the Exports (in Local Currency Unit) of 1960 in Luxembourg to that in Malawi?
Provide a succinct answer. 30.12. What is the ratio of the Exports (in Local Currency Unit) of 1961 in Luxembourg to that in Malawi?
Your response must be concise. 30.23. What is the ratio of the Exports (in Local Currency Unit) of 1962 in Luxembourg to that in Malawi?
Make the answer very short. 26.85. What is the ratio of the Exports (in Local Currency Unit) in 1963 in Luxembourg to that in Malawi?
Offer a very short reply. 26.16. What is the ratio of the Exports (in Local Currency Unit) in 1960 in Luxembourg to that in Malaysia?
Make the answer very short. 0.2. What is the ratio of the Exports (in Local Currency Unit) of 1961 in Luxembourg to that in Malaysia?
Ensure brevity in your answer.  0.23. What is the ratio of the Exports (in Local Currency Unit) in 1962 in Luxembourg to that in Malaysia?
Keep it short and to the point. 0.22. What is the ratio of the Exports (in Local Currency Unit) of 1963 in Luxembourg to that in Malaysia?
Offer a very short reply. 0.22. What is the ratio of the Exports (in Local Currency Unit) in 1960 in Madagascar to that in Malawi?
Give a very brief answer. 129.69. What is the ratio of the Exports (in Local Currency Unit) in 1961 in Madagascar to that in Malawi?
Your answer should be compact. 196.16. What is the ratio of the Exports (in Local Currency Unit) of 1962 in Madagascar to that in Malawi?
Offer a very short reply. 179.3. What is the ratio of the Exports (in Local Currency Unit) in 1963 in Madagascar to that in Malawi?
Provide a short and direct response. 160.78. What is the ratio of the Exports (in Local Currency Unit) in 1960 in Madagascar to that in Malaysia?
Your response must be concise. 0.88. What is the ratio of the Exports (in Local Currency Unit) of 1961 in Madagascar to that in Malaysia?
Offer a very short reply. 1.47. What is the ratio of the Exports (in Local Currency Unit) in 1962 in Madagascar to that in Malaysia?
Give a very brief answer. 1.46. What is the ratio of the Exports (in Local Currency Unit) of 1963 in Madagascar to that in Malaysia?
Provide a short and direct response. 1.36. What is the ratio of the Exports (in Local Currency Unit) of 1960 in Malawi to that in Malaysia?
Your answer should be very brief. 0.01. What is the ratio of the Exports (in Local Currency Unit) of 1961 in Malawi to that in Malaysia?
Your answer should be very brief. 0.01. What is the ratio of the Exports (in Local Currency Unit) of 1962 in Malawi to that in Malaysia?
Provide a succinct answer. 0.01. What is the ratio of the Exports (in Local Currency Unit) in 1963 in Malawi to that in Malaysia?
Offer a terse response. 0.01. What is the difference between the highest and the second highest Exports (in Local Currency Unit) of 1960?
Offer a terse response. 3.98e+09. What is the difference between the highest and the second highest Exports (in Local Currency Unit) of 1961?
Ensure brevity in your answer.  1.05e+1. What is the difference between the highest and the second highest Exports (in Local Currency Unit) of 1962?
Offer a terse response. 1.24e+1. What is the difference between the highest and the second highest Exports (in Local Currency Unit) in 1963?
Ensure brevity in your answer.  1.85e+1. What is the difference between the highest and the lowest Exports (in Local Currency Unit) in 1960?
Offer a very short reply. 7.73e+09. What is the difference between the highest and the lowest Exports (in Local Currency Unit) in 1961?
Your answer should be very brief. 1.55e+1. What is the difference between the highest and the lowest Exports (in Local Currency Unit) in 1962?
Offer a very short reply. 1.74e+1. What is the difference between the highest and the lowest Exports (in Local Currency Unit) in 1963?
Provide a short and direct response. 2.32e+1. 